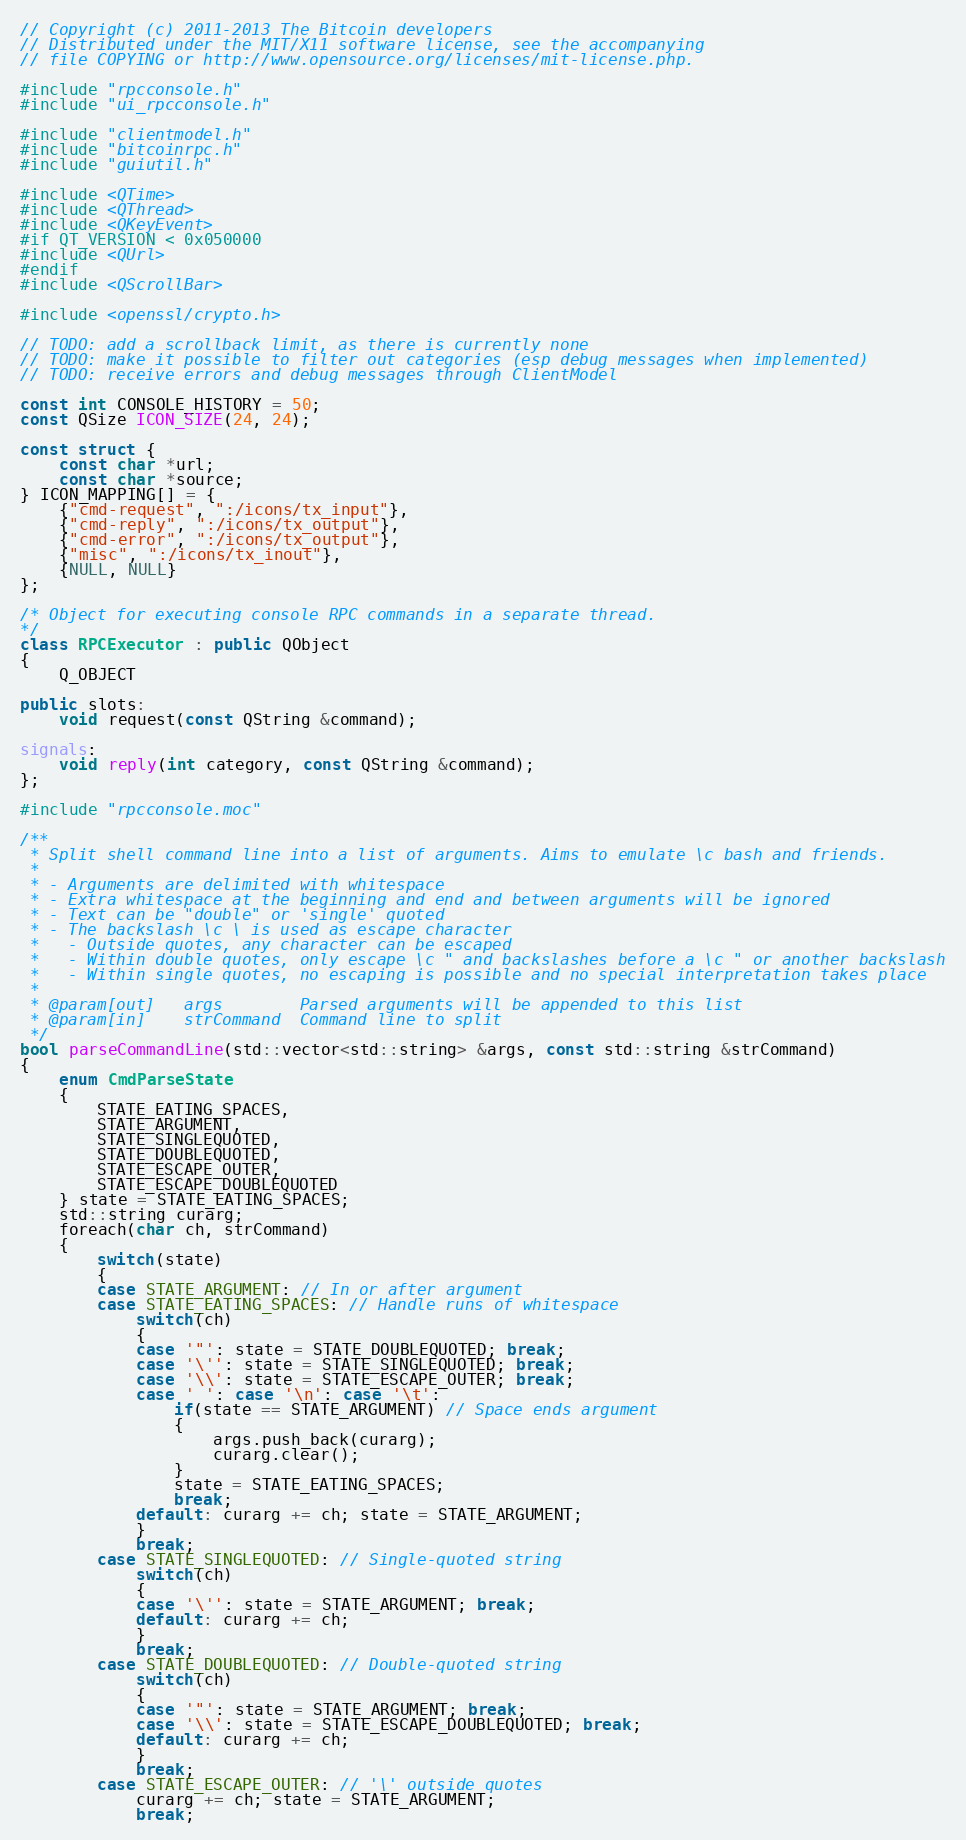Convert code to text. <code><loc_0><loc_0><loc_500><loc_500><_C++_>// Copyright (c) 2011-2013 The Bitcoin developers
// Distributed under the MIT/X11 software license, see the accompanying
// file COPYING or http://www.opensource.org/licenses/mit-license.php.

#include "rpcconsole.h"
#include "ui_rpcconsole.h"

#include "clientmodel.h"
#include "bitcoinrpc.h"
#include "guiutil.h"

#include <QTime>
#include <QThread>
#include <QKeyEvent>
#if QT_VERSION < 0x050000
#include <QUrl>
#endif
#include <QScrollBar>

#include <openssl/crypto.h>

// TODO: add a scrollback limit, as there is currently none
// TODO: make it possible to filter out categories (esp debug messages when implemented)
// TODO: receive errors and debug messages through ClientModel

const int CONSOLE_HISTORY = 50;
const QSize ICON_SIZE(24, 24);

const struct {
    const char *url;
    const char *source;
} ICON_MAPPING[] = {
    {"cmd-request", ":/icons/tx_input"},
    {"cmd-reply", ":/icons/tx_output"},
    {"cmd-error", ":/icons/tx_output"},
    {"misc", ":/icons/tx_inout"},
    {NULL, NULL}
};

/* Object for executing console RPC commands in a separate thread.
*/
class RPCExecutor : public QObject
{
    Q_OBJECT

public slots:
    void request(const QString &command);

signals:
    void reply(int category, const QString &command);
};

#include "rpcconsole.moc"

/**
 * Split shell command line into a list of arguments. Aims to emulate \c bash and friends.
 *
 * - Arguments are delimited with whitespace
 * - Extra whitespace at the beginning and end and between arguments will be ignored
 * - Text can be "double" or 'single' quoted
 * - The backslash \c \ is used as escape character
 *   - Outside quotes, any character can be escaped
 *   - Within double quotes, only escape \c " and backslashes before a \c " or another backslash
 *   - Within single quotes, no escaping is possible and no special interpretation takes place
 *
 * @param[out]   args        Parsed arguments will be appended to this list
 * @param[in]    strCommand  Command line to split
 */
bool parseCommandLine(std::vector<std::string> &args, const std::string &strCommand)
{
    enum CmdParseState
    {
        STATE_EATING_SPACES,
        STATE_ARGUMENT,
        STATE_SINGLEQUOTED,
        STATE_DOUBLEQUOTED,
        STATE_ESCAPE_OUTER,
        STATE_ESCAPE_DOUBLEQUOTED
    } state = STATE_EATING_SPACES;
    std::string curarg;
    foreach(char ch, strCommand)
    {
        switch(state)
        {
        case STATE_ARGUMENT: // In or after argument
        case STATE_EATING_SPACES: // Handle runs of whitespace
            switch(ch)
            {
            case '"': state = STATE_DOUBLEQUOTED; break;
            case '\'': state = STATE_SINGLEQUOTED; break;
            case '\\': state = STATE_ESCAPE_OUTER; break;
            case ' ': case '\n': case '\t':
                if(state == STATE_ARGUMENT) // Space ends argument
                {
                    args.push_back(curarg);
                    curarg.clear();
                }
                state = STATE_EATING_SPACES;
                break;
            default: curarg += ch; state = STATE_ARGUMENT;
            }
            break;
        case STATE_SINGLEQUOTED: // Single-quoted string
            switch(ch)
            {
            case '\'': state = STATE_ARGUMENT; break;
            default: curarg += ch;
            }
            break;
        case STATE_DOUBLEQUOTED: // Double-quoted string
            switch(ch)
            {
            case '"': state = STATE_ARGUMENT; break;
            case '\\': state = STATE_ESCAPE_DOUBLEQUOTED; break;
            default: curarg += ch;
            }
            break;
        case STATE_ESCAPE_OUTER: // '\' outside quotes
            curarg += ch; state = STATE_ARGUMENT;
            break;</code> 